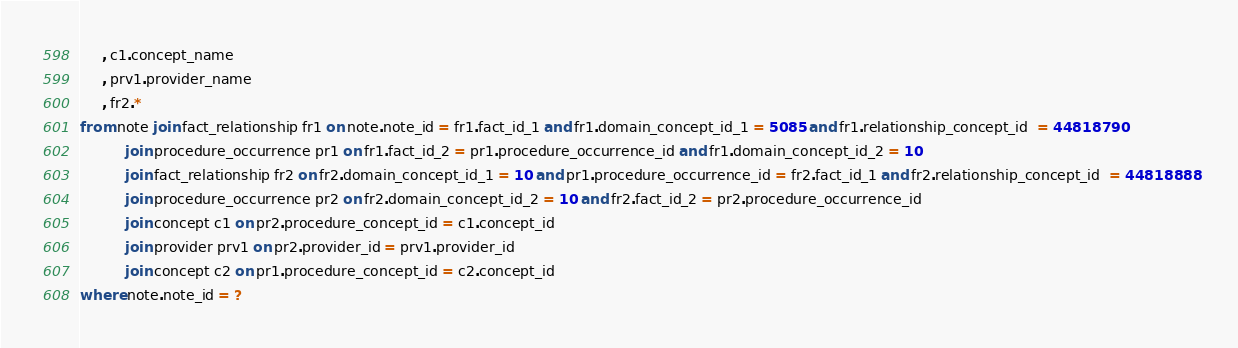<code> <loc_0><loc_0><loc_500><loc_500><_SQL_>	 , c1.concept_name
	 , prv1.provider_name
	 , fr2.*
from note join fact_relationship fr1 on note.note_id = fr1.fact_id_1 and fr1.domain_concept_id_1 = 5085 and fr1.relationship_concept_id  = 44818790
          join procedure_occurrence pr1 on fr1.fact_id_2 = pr1.procedure_occurrence_id and fr1.domain_concept_id_2 = 10
          join fact_relationship fr2 on fr2.domain_concept_id_1 = 10 and pr1.procedure_occurrence_id = fr2.fact_id_1 and fr2.relationship_concept_id  = 44818888
          join procedure_occurrence pr2 on fr2.domain_concept_id_2 = 10 and fr2.fact_id_2 = pr2.procedure_occurrence_id
          join concept c1 on pr2.procedure_concept_id = c1.concept_id
          join provider prv1 on pr2.provider_id = prv1.provider_id
          join concept c2 on pr1.procedure_concept_id = c2.concept_id
where note.note_id = ?
</code> 